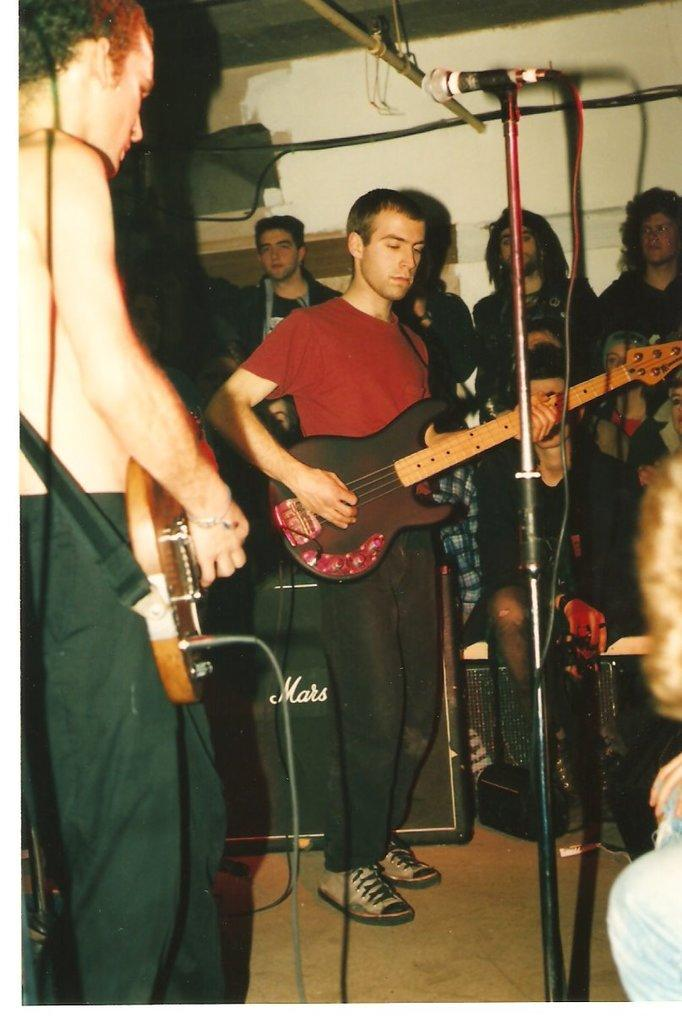What are the two persons in the image doing? The two persons in the image are playing guitar. Can you describe the people in the background of the image? There are additional people standing in the background of the image. What type of straw is being used to observe the guitar players in the image? There is no straw present in the image, and no one is using a straw to observe the guitar players. 